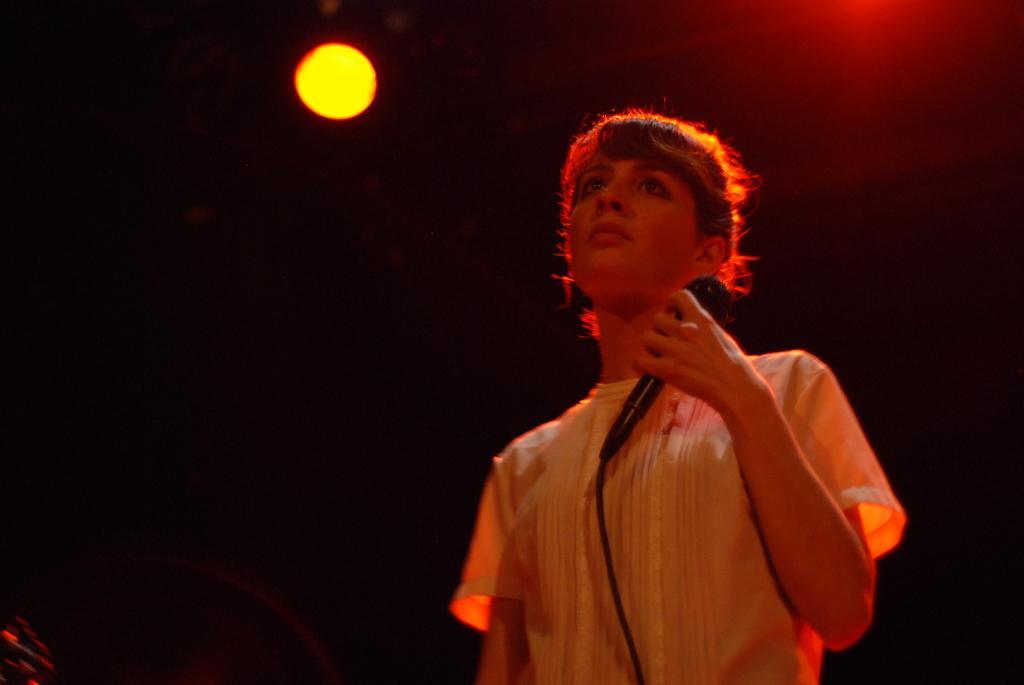In one or two sentences, can you explain what this image depicts? In this picture I can see a person holding the microphone. I can see the light. 